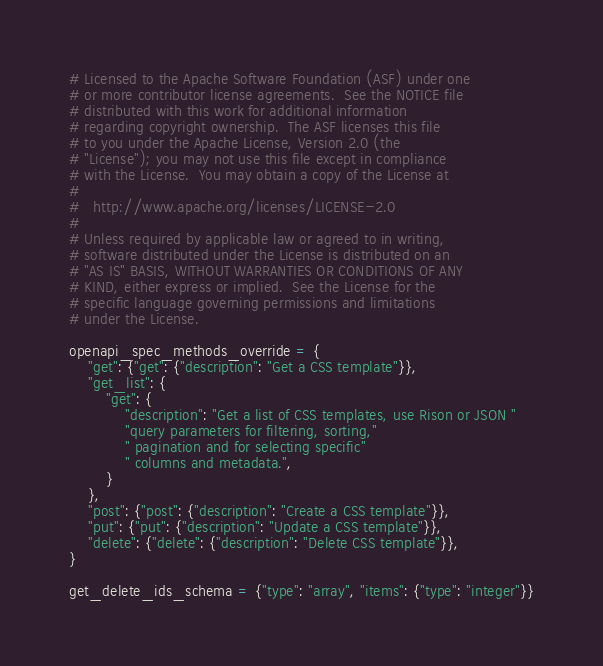<code> <loc_0><loc_0><loc_500><loc_500><_Python_># Licensed to the Apache Software Foundation (ASF) under one
# or more contributor license agreements.  See the NOTICE file
# distributed with this work for additional information
# regarding copyright ownership.  The ASF licenses this file
# to you under the Apache License, Version 2.0 (the
# "License"); you may not use this file except in compliance
# with the License.  You may obtain a copy of the License at
#
#   http://www.apache.org/licenses/LICENSE-2.0
#
# Unless required by applicable law or agreed to in writing,
# software distributed under the License is distributed on an
# "AS IS" BASIS, WITHOUT WARRANTIES OR CONDITIONS OF ANY
# KIND, either express or implied.  See the License for the
# specific language governing permissions and limitations
# under the License.

openapi_spec_methods_override = {
    "get": {"get": {"description": "Get a CSS template"}},
    "get_list": {
        "get": {
            "description": "Get a list of CSS templates, use Rison or JSON "
            "query parameters for filtering, sorting,"
            " pagination and for selecting specific"
            " columns and metadata.",
        }
    },
    "post": {"post": {"description": "Create a CSS template"}},
    "put": {"put": {"description": "Update a CSS template"}},
    "delete": {"delete": {"description": "Delete CSS template"}},
}

get_delete_ids_schema = {"type": "array", "items": {"type": "integer"}}
</code> 